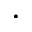Convert formula to latex. <formula><loc_0><loc_0><loc_500><loc_500>\cdot</formula> 